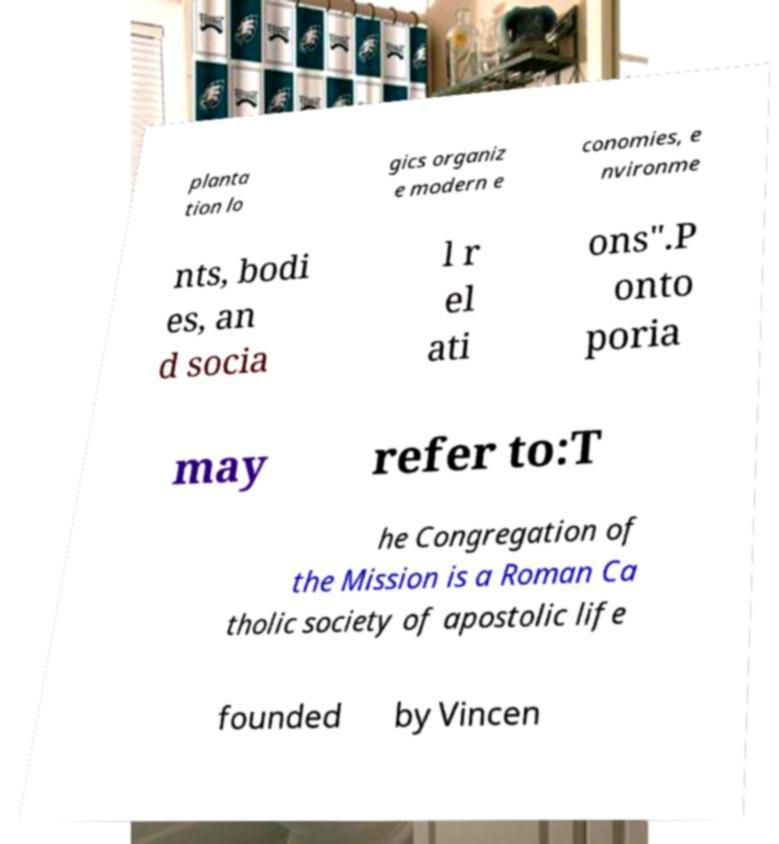Please read and relay the text visible in this image. What does it say? planta tion lo gics organiz e modern e conomies, e nvironme nts, bodi es, an d socia l r el ati ons".P onto poria may refer to:T he Congregation of the Mission is a Roman Ca tholic society of apostolic life founded by Vincen 